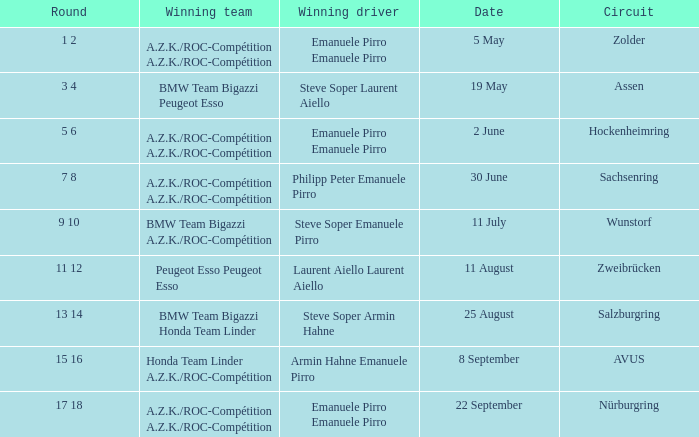What was the winning team on 11 July? BMW Team Bigazzi A.Z.K./ROC-Compétition. 